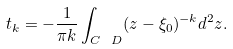Convert formula to latex. <formula><loc_0><loc_0><loc_500><loc_500>t _ { k } = - \frac { 1 } { \pi k } \int _ { { C } \ D } ( z - \xi _ { 0 } ) ^ { - k } d ^ { 2 } z .</formula> 